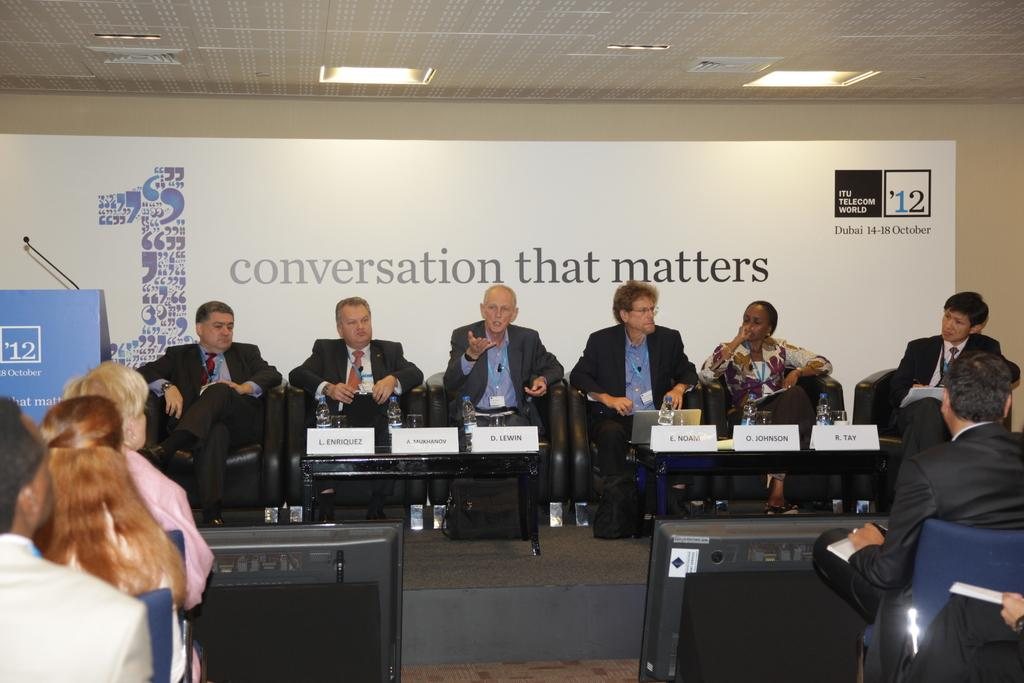What are the people in the image doing? The people in the image are sitting. How are the people arranged in the image? Some people are sitting in front of others. Can you describe the man in the center of the group? The man in the center of the group is a man. What is the man in the center doing? The man in the center is talking. What can be seen in the background of the image? There is a hoarding visible in the background of the image. What type of brass instrument is being played by the man in the center of the group? There is no brass instrument present in the image; the man in the center is talking. How many additions were made to the group after the original photo was taken? There is no information about any additions to the group or any original photo, as the image only shows the people sitting together. 